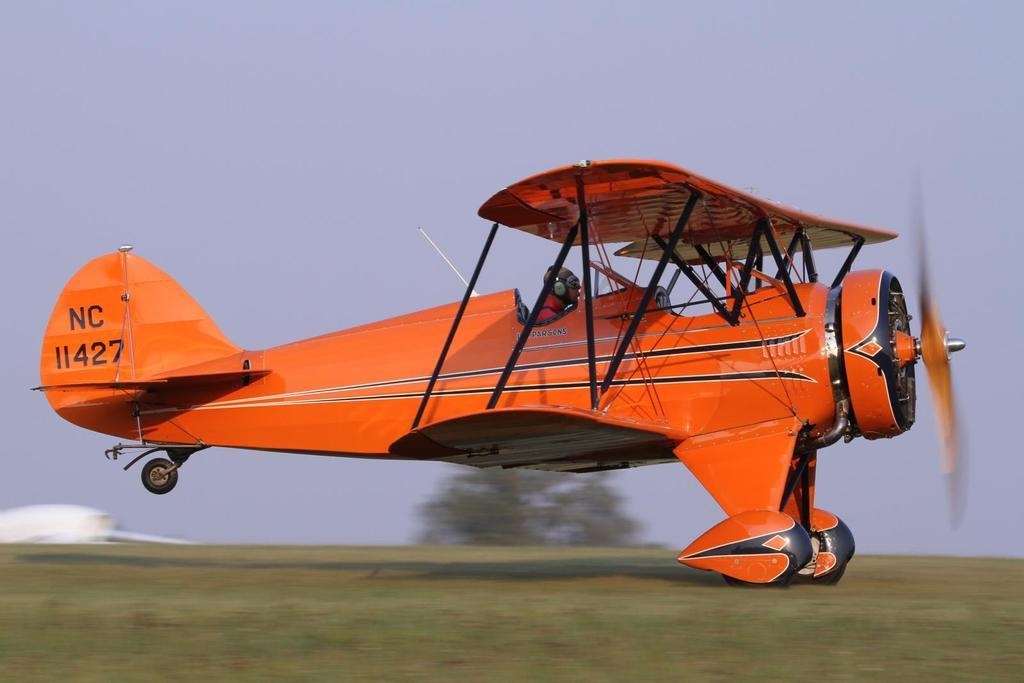<image>
Relay a brief, clear account of the picture shown. A red plane has NC printed on the tail over some numbers. 